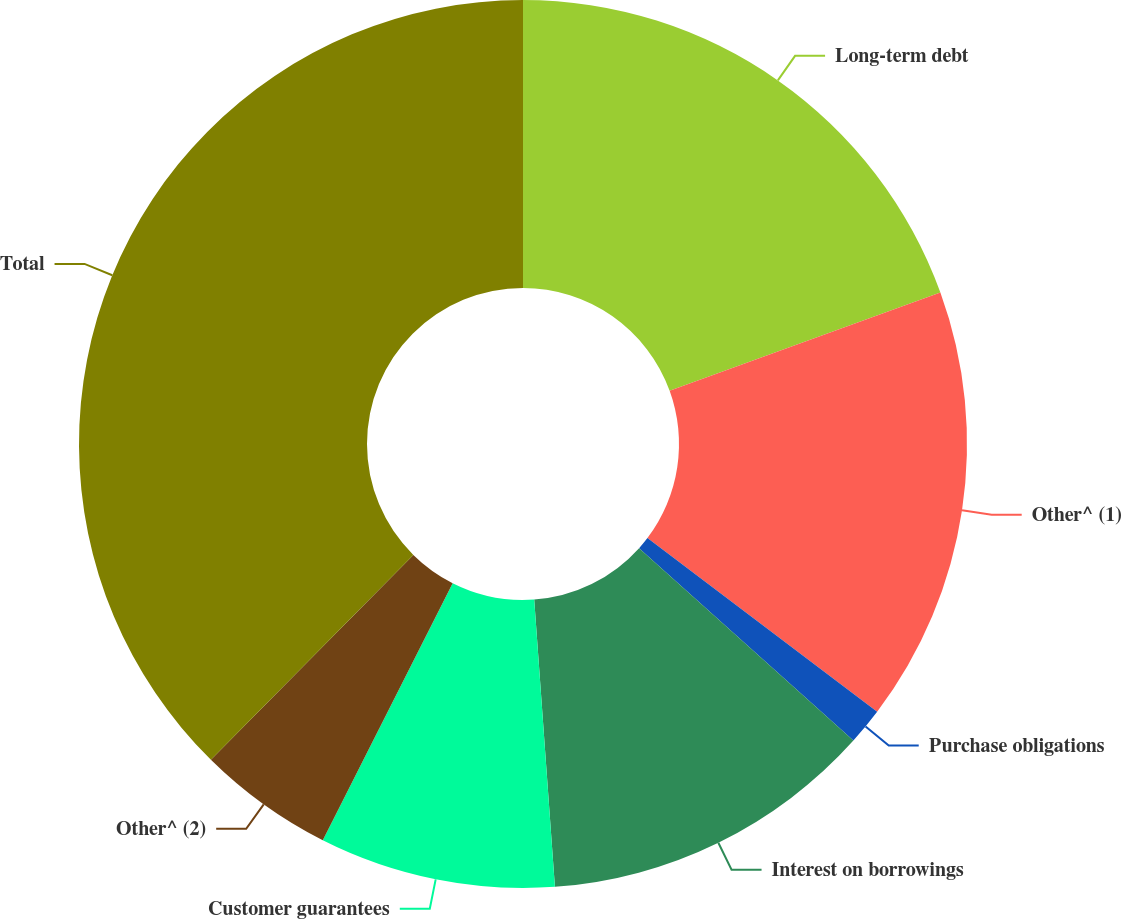Convert chart. <chart><loc_0><loc_0><loc_500><loc_500><pie_chart><fcel>Long-term debt<fcel>Other^ (1)<fcel>Purchase obligations<fcel>Interest on borrowings<fcel>Customer guarantees<fcel>Other^ (2)<fcel>Total<nl><fcel>19.46%<fcel>15.84%<fcel>1.34%<fcel>12.21%<fcel>8.59%<fcel>4.96%<fcel>37.59%<nl></chart> 